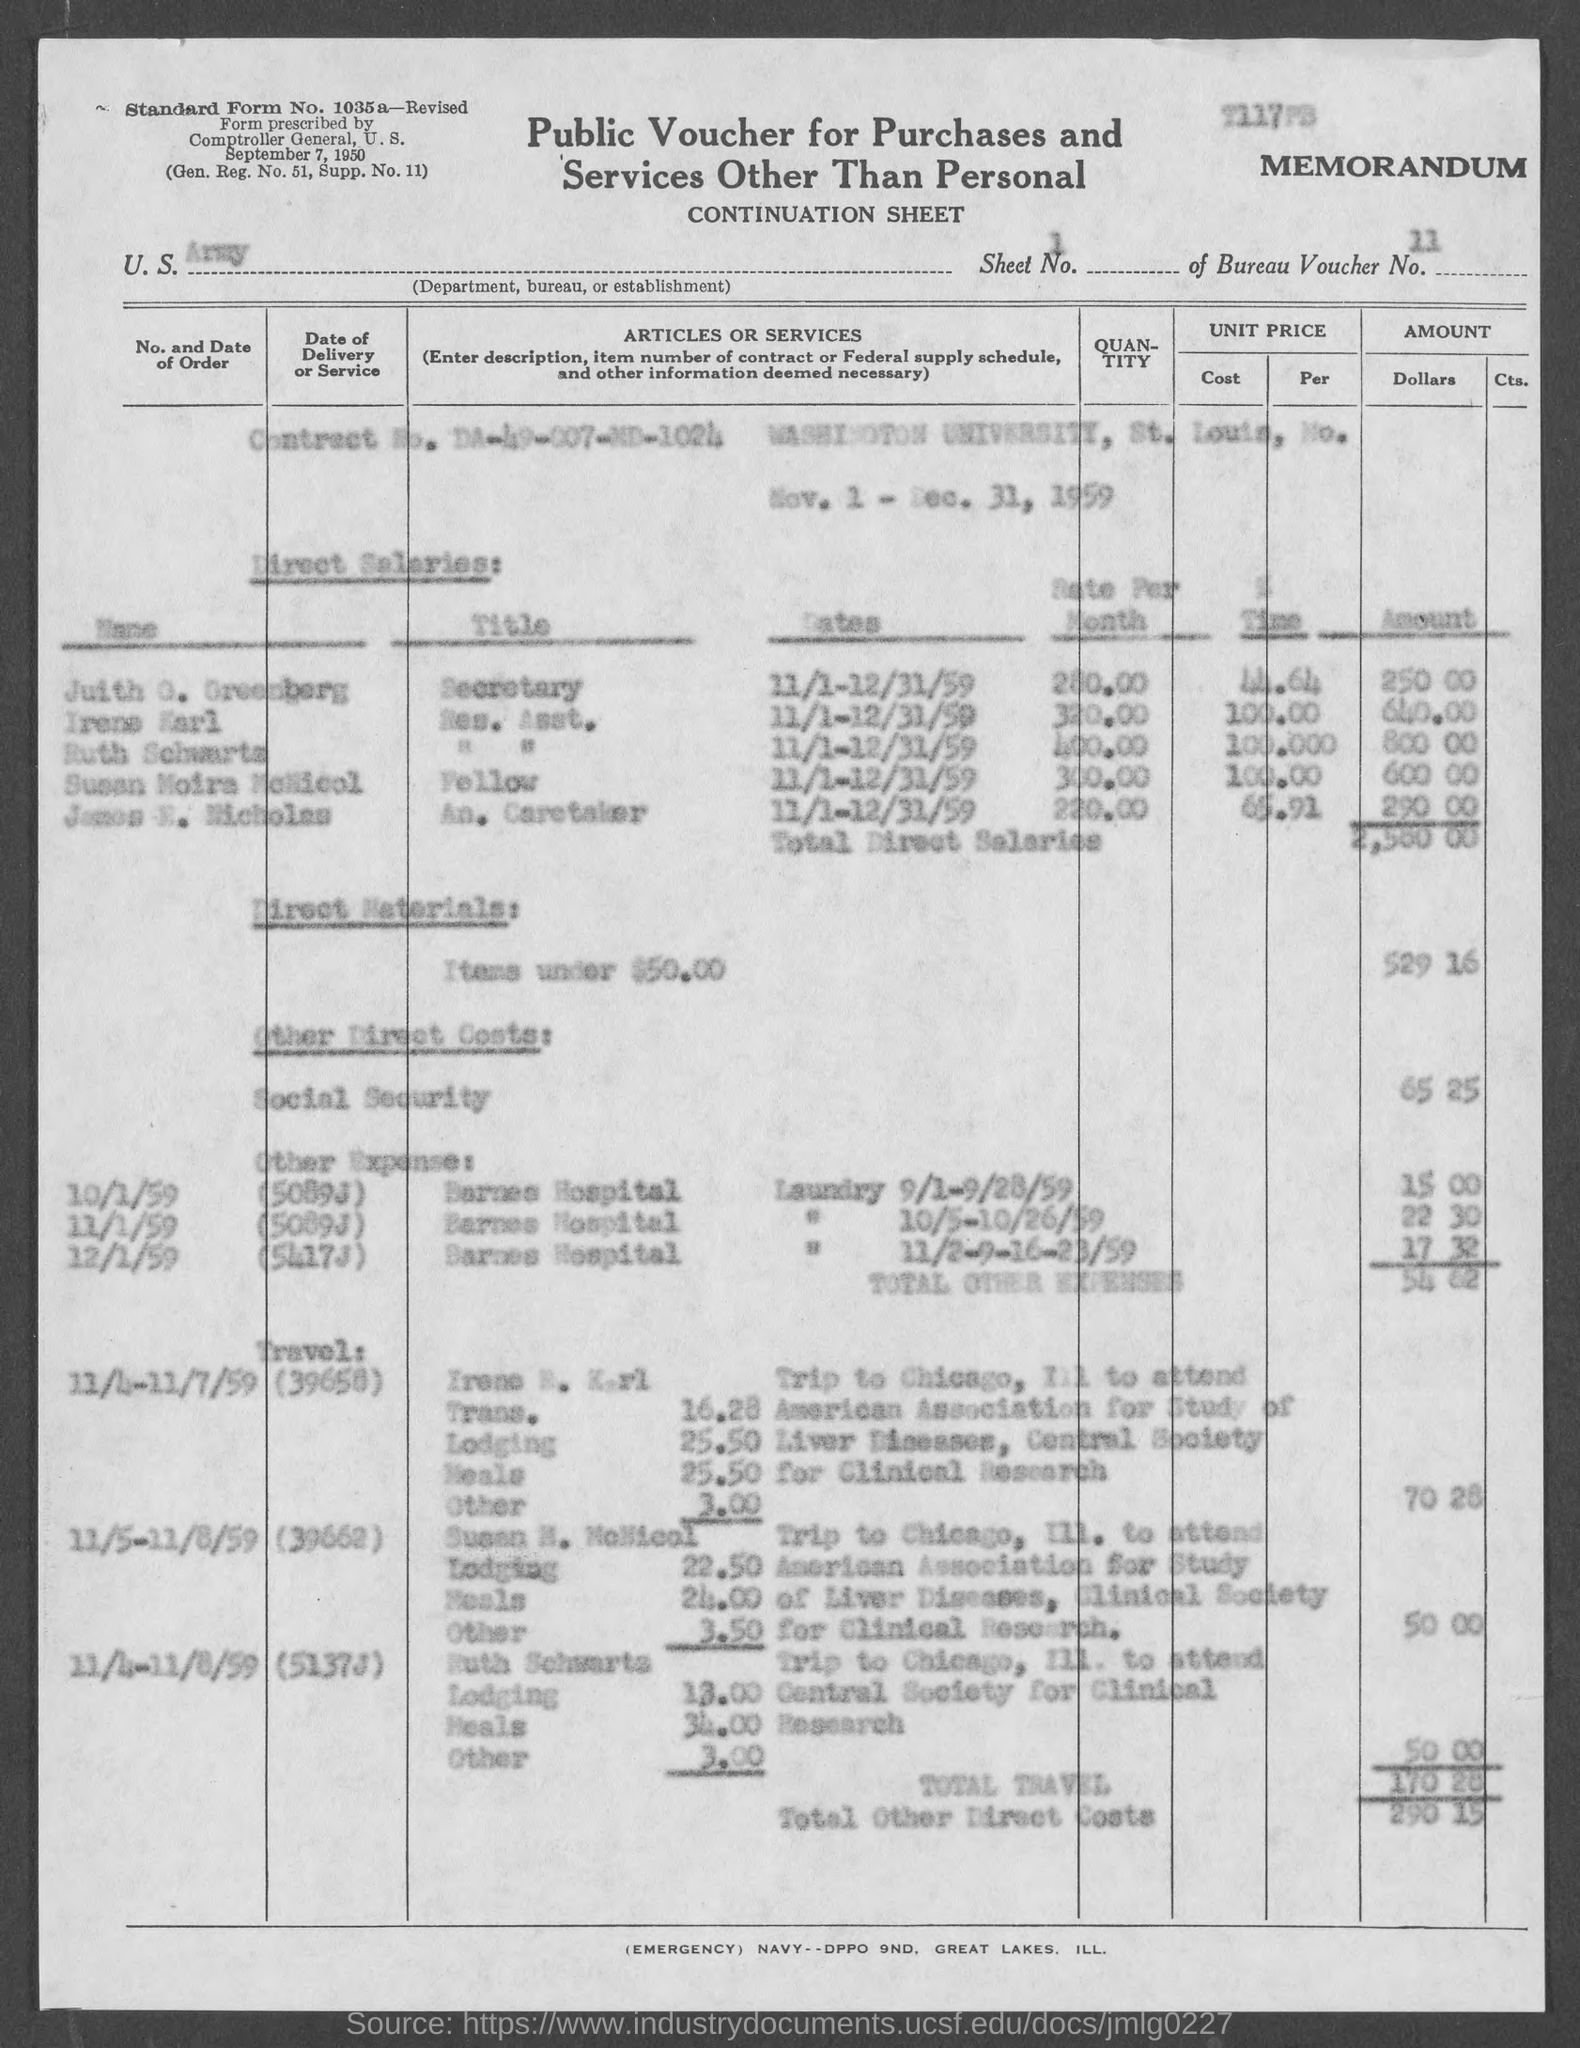Give some essential details in this illustration. The voucher refers to the U.S. Army as the department, bureau, or establishment mentioned in the document. The contract number given in the voucher is DA-49-007-ND-1024. The total travel cost mentioned in the voucher is 170.28... The Bureau Voucher No. mentioned in the document is 11. The sheet number mentioned in the voucher is 1. 